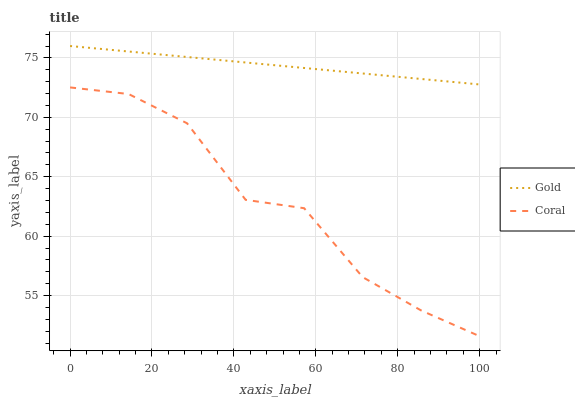Does Coral have the minimum area under the curve?
Answer yes or no. Yes. Does Gold have the maximum area under the curve?
Answer yes or no. Yes. Does Gold have the minimum area under the curve?
Answer yes or no. No. Is Gold the smoothest?
Answer yes or no. Yes. Is Coral the roughest?
Answer yes or no. Yes. Is Gold the roughest?
Answer yes or no. No. Does Coral have the lowest value?
Answer yes or no. Yes. Does Gold have the lowest value?
Answer yes or no. No. Does Gold have the highest value?
Answer yes or no. Yes. Is Coral less than Gold?
Answer yes or no. Yes. Is Gold greater than Coral?
Answer yes or no. Yes. Does Coral intersect Gold?
Answer yes or no. No. 